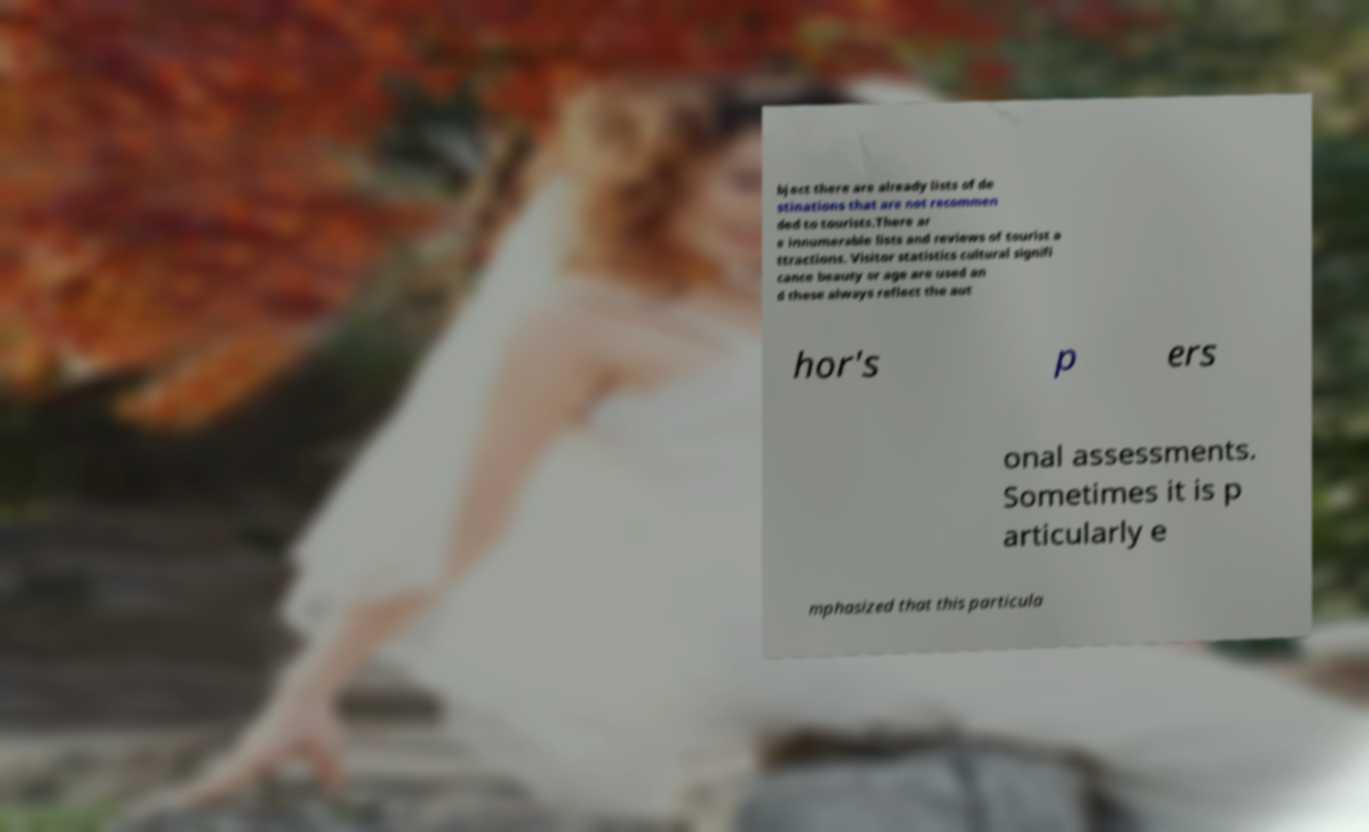What messages or text are displayed in this image? I need them in a readable, typed format. bject there are already lists of de stinations that are not recommen ded to tourists.There ar e innumerable lists and reviews of tourist a ttractions. Visitor statistics cultural signifi cance beauty or age are used an d these always reflect the aut hor's p ers onal assessments. Sometimes it is p articularly e mphasized that this particula 